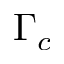<formula> <loc_0><loc_0><loc_500><loc_500>\Gamma _ { c }</formula> 